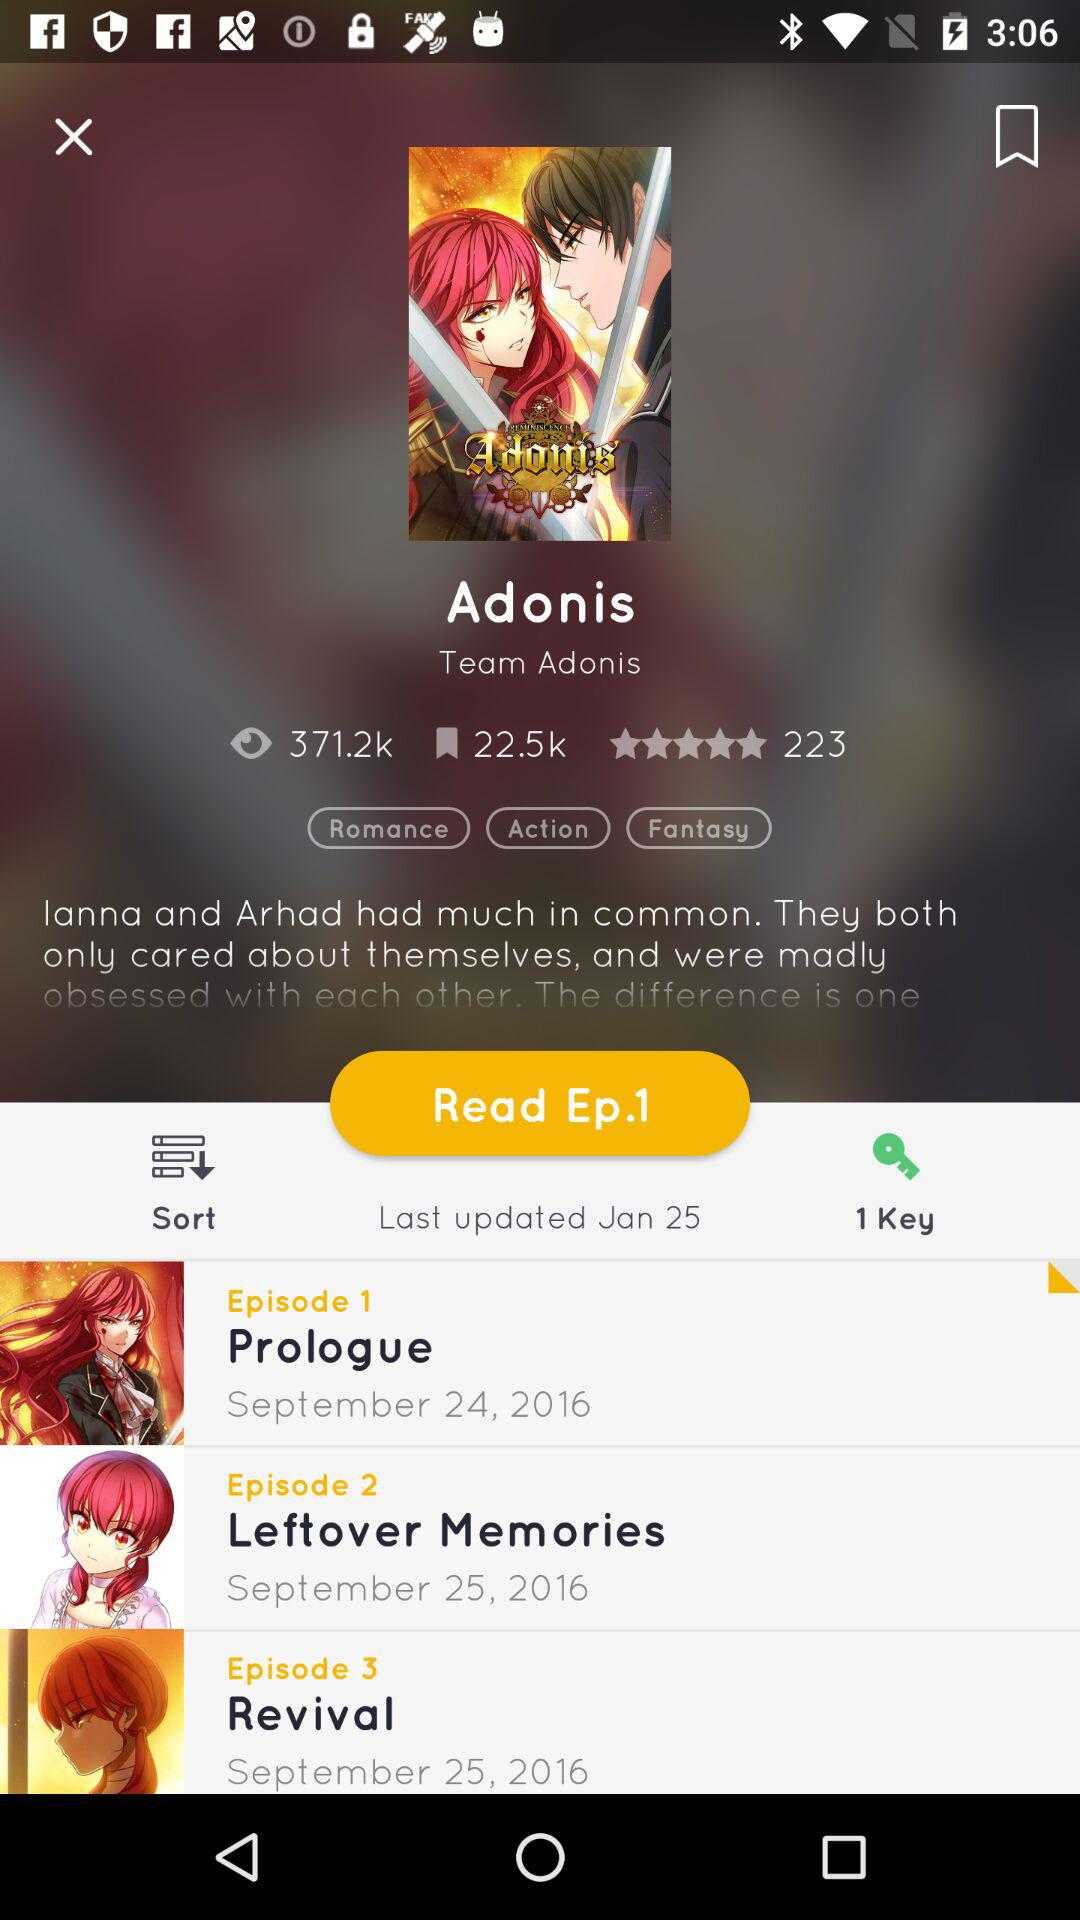What are the ratings? The rating is 5 stars. 